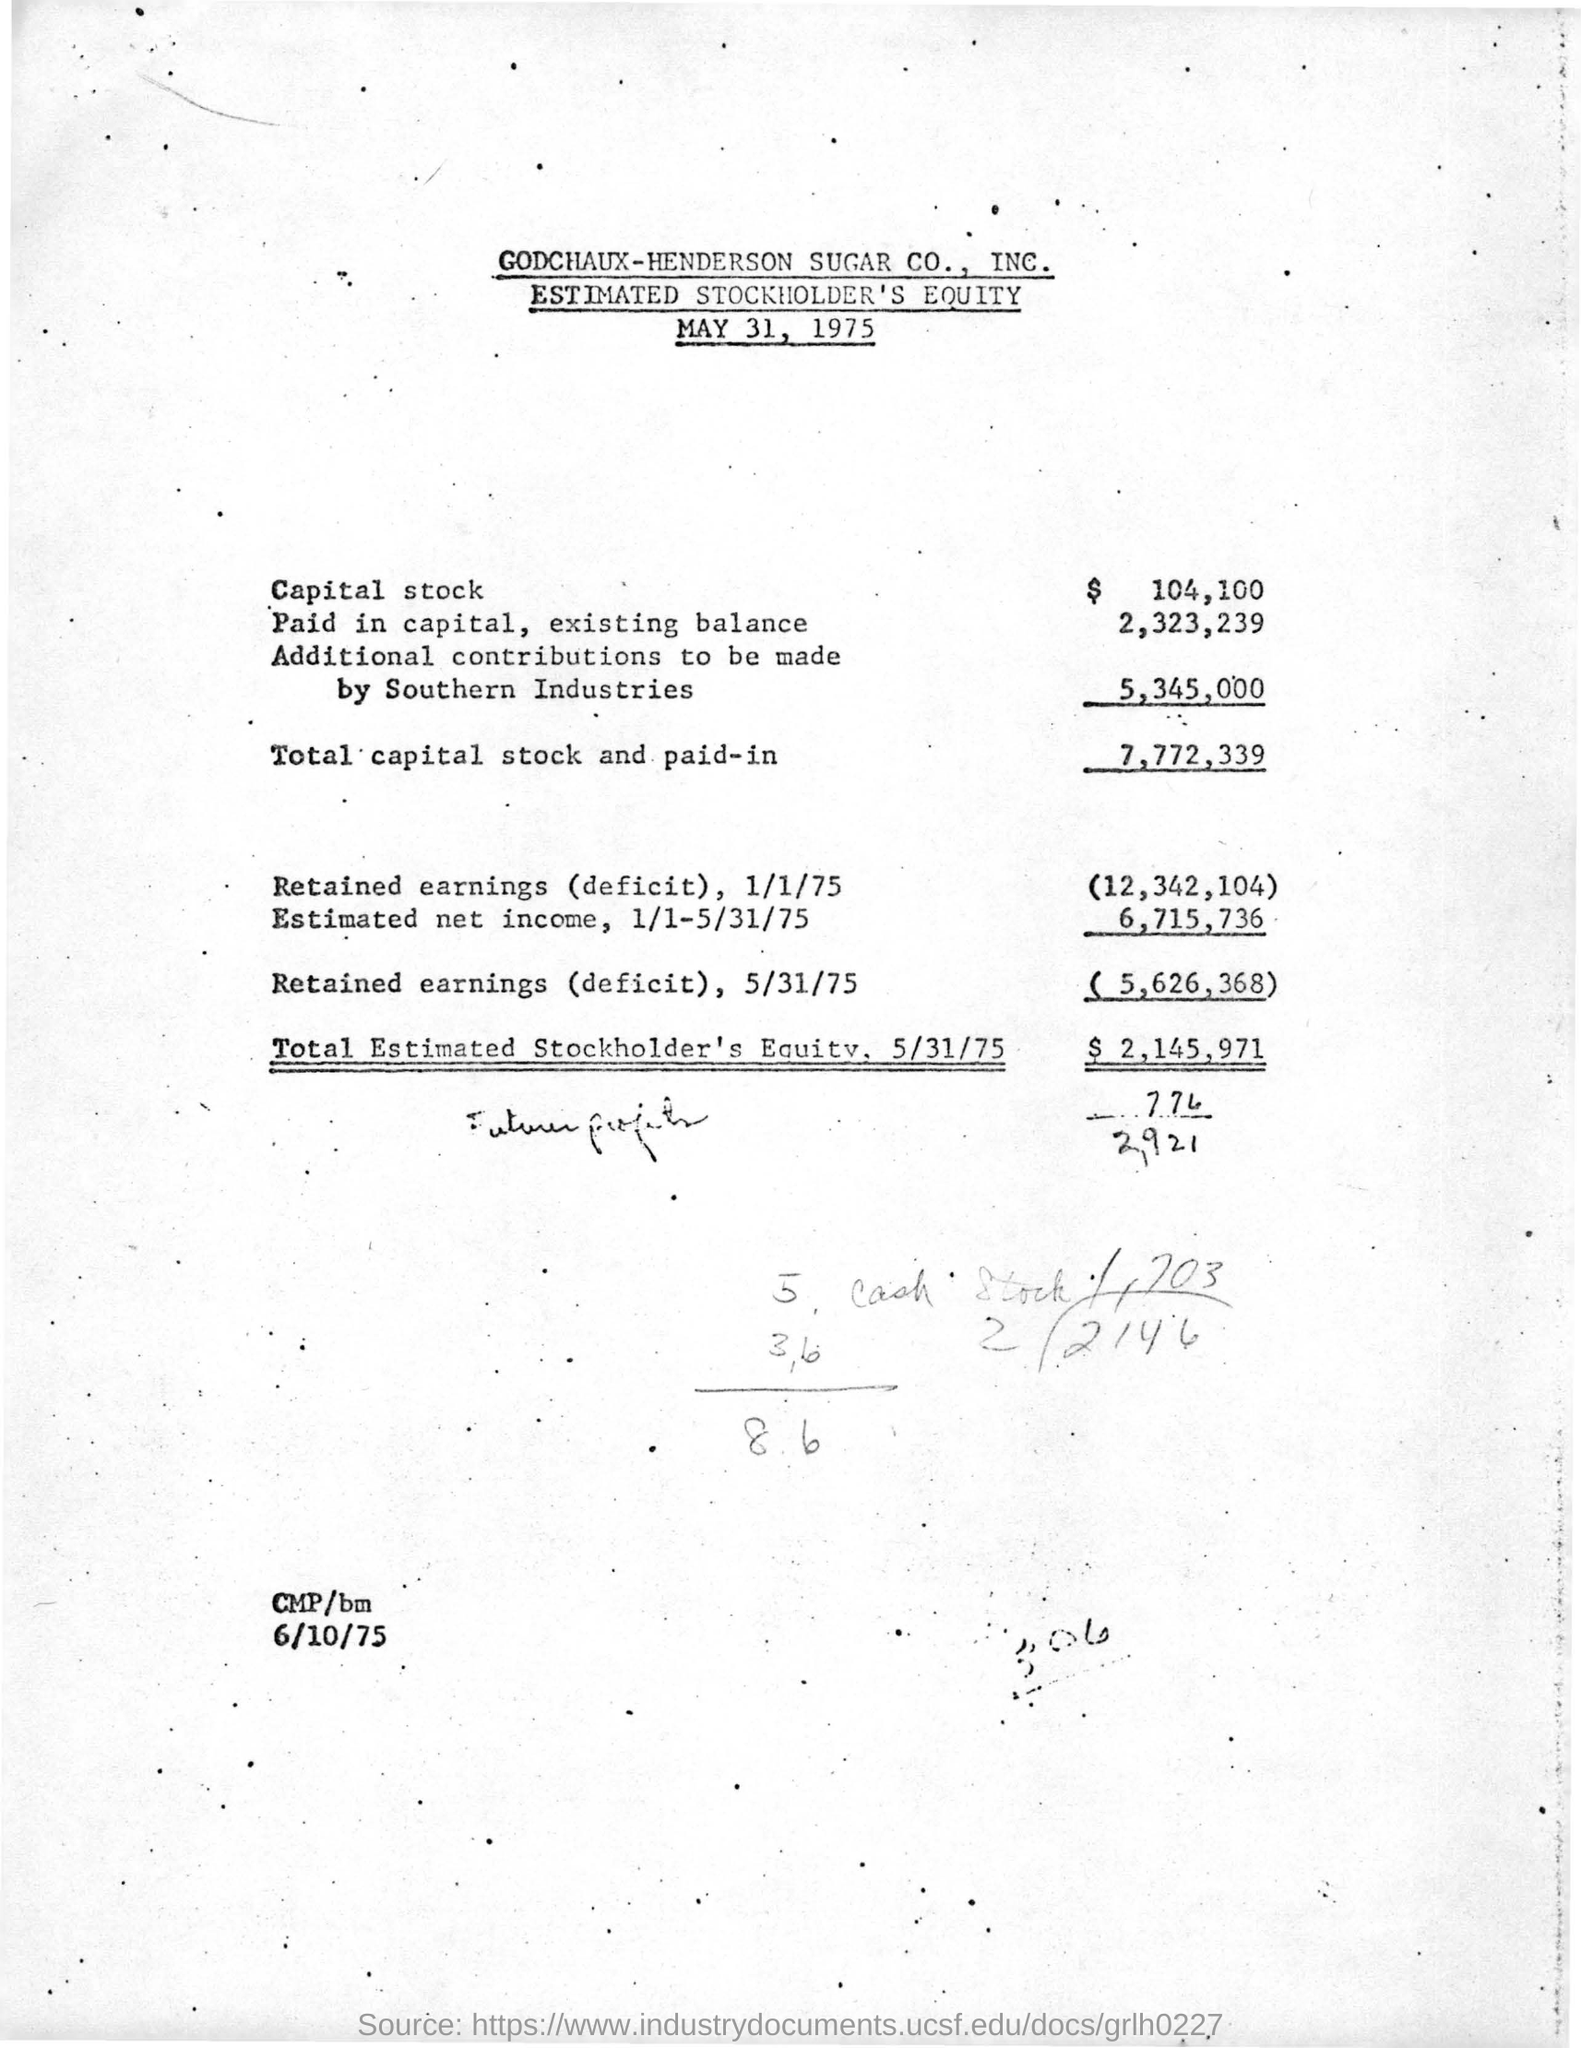What is the issued date of this document?
Give a very brief answer. MAY 31, 1975. How much is the total capital stock and paid-in?
Make the answer very short. 7,772,339. What is this document about?
Give a very brief answer. Estimated Stockholder's Equity. How much is the estimated net income,  1/1-5/31/75?
Your answer should be compact. 6,715,736. How much is the Total Estimated Stockholder's Equity,  5/31/75?
Ensure brevity in your answer.  $  2,145,971. 